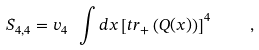<formula> <loc_0><loc_0><loc_500><loc_500>S _ { 4 , 4 } = v _ { 4 } \ \int d { x } \left [ t r _ { + } \left ( Q ( { x } ) \right ) \right ] ^ { 4 } \quad ,</formula> 